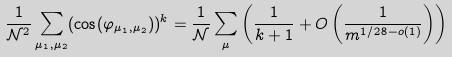<formula> <loc_0><loc_0><loc_500><loc_500>\frac { 1 } { \mathcal { N } ^ { 2 } } \sum _ { \mu _ { 1 } , \mu _ { 2 } } ( \cos ( \varphi _ { \mu _ { 1 } , \mu _ { 2 } } ) ) ^ { k } = \frac { 1 } { \mathcal { N } } \sum _ { \mu } \left ( \frac { 1 } { k + 1 } + O \left ( \frac { 1 } { m ^ { 1 / 2 8 - o ( 1 ) } } \right ) \right )</formula> 